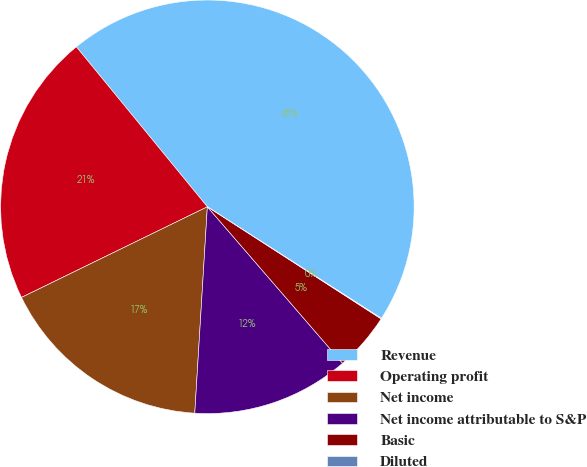Convert chart to OTSL. <chart><loc_0><loc_0><loc_500><loc_500><pie_chart><fcel>Revenue<fcel>Operating profit<fcel>Net income<fcel>Net income attributable to S&P<fcel>Basic<fcel>Diluted<nl><fcel>44.99%<fcel>21.3%<fcel>16.81%<fcel>12.31%<fcel>4.54%<fcel>0.05%<nl></chart> 